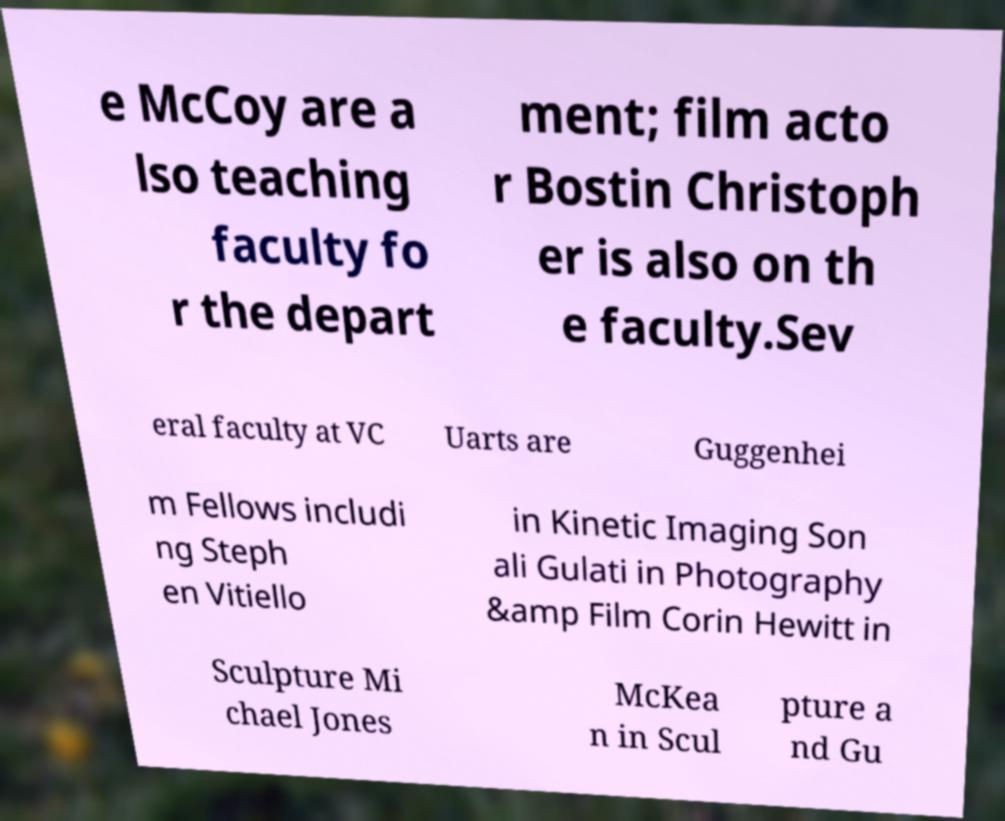What messages or text are displayed in this image? I need them in a readable, typed format. e McCoy are a lso teaching faculty fo r the depart ment; film acto r Bostin Christoph er is also on th e faculty.Sev eral faculty at VC Uarts are Guggenhei m Fellows includi ng Steph en Vitiello in Kinetic Imaging Son ali Gulati in Photography &amp Film Corin Hewitt in Sculpture Mi chael Jones McKea n in Scul pture a nd Gu 